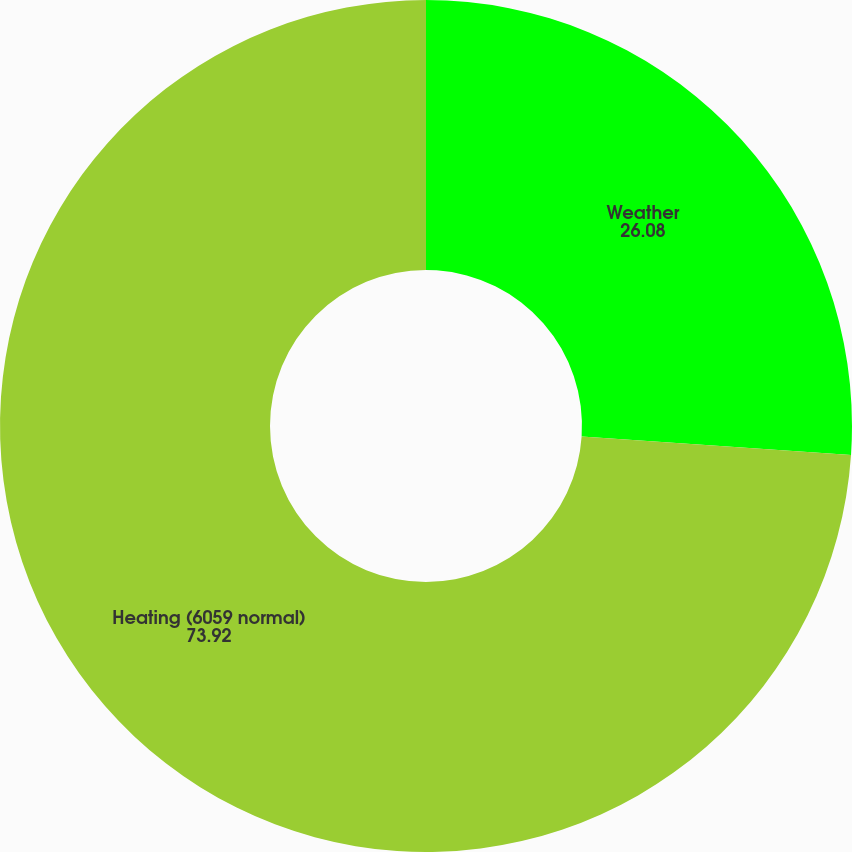Convert chart to OTSL. <chart><loc_0><loc_0><loc_500><loc_500><pie_chart><fcel>Weather<fcel>Heating (6059 normal)<nl><fcel>26.08%<fcel>73.92%<nl></chart> 